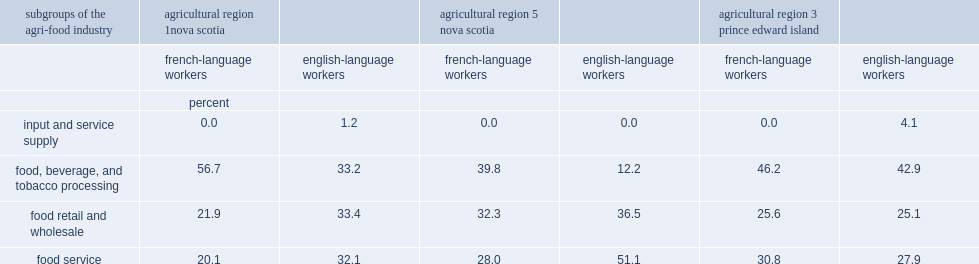Which sector of workers in nova scotia had fewer food retial and wholesale sector and food service sector? french-language workers or english-language workers? French-language workers french-language workers. In prince edward island's agricultural region 3, which sector workers had a lower proportion in the supply sector? english-language workers or french-language workers? French-language workers. In prince edward island's agricultural region 3, which sector workers had a lower proportion in the food service sector? english-language workers or french-language workers? French-language workers. 